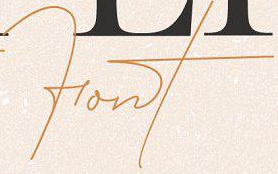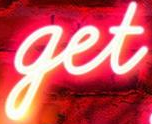What text appears in these images from left to right, separated by a semicolon? Font; get 